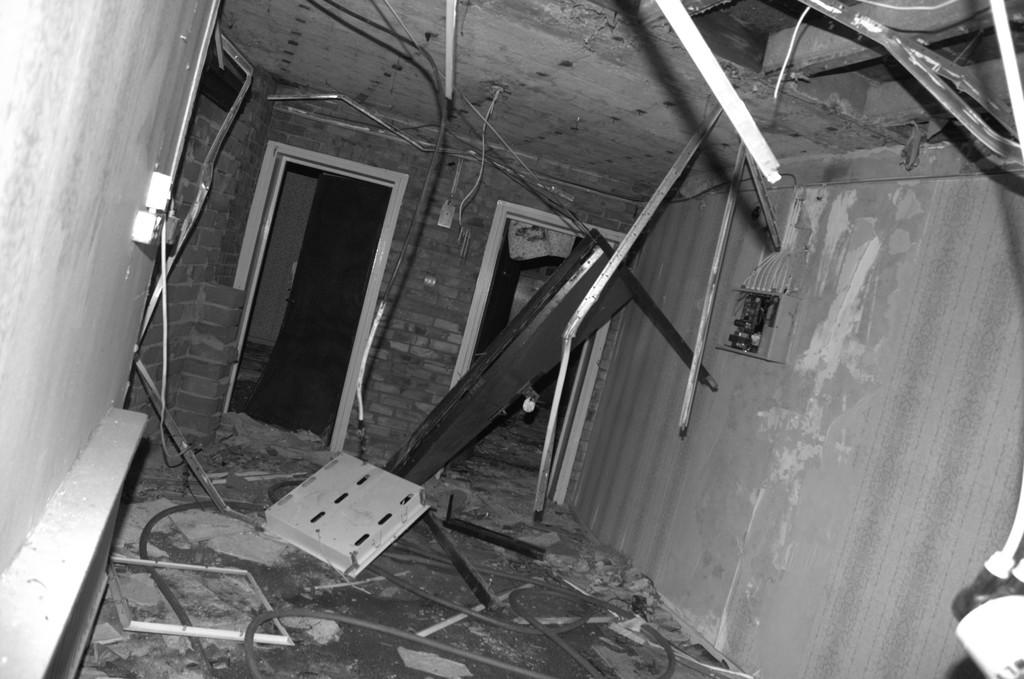Where was the image taken? The image was taken inside a building. What can be seen supporting something in the image? There are metal stands in the image. What are the openings that can be used to enter or exit the building? There are doors in the image. What is on the left side of the image? There is a wall on the left side of the image. What is the surface that people walk on in the image? There is a floor at the bottom of the image. What is above the image to protect from weather or provide shelter? There is a roof at the top of the image. What type of substance is being transported by the trains in the image? There are no trains present in the image, so it is not possible to determine what type of substance might be transported. 